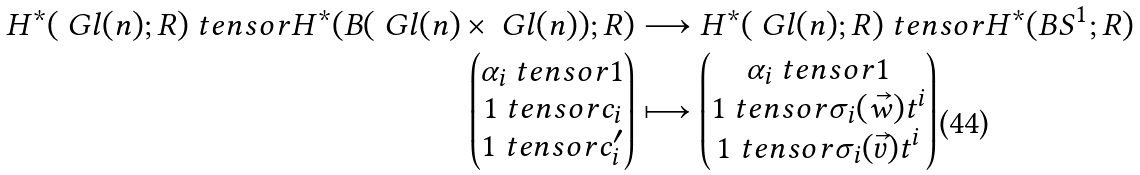Convert formula to latex. <formula><loc_0><loc_0><loc_500><loc_500>H ^ { * } ( \ G l ( n ) ; R ) \ t e n s o r H ^ { * } ( B ( \ G l ( n ) \times \ G l ( n ) ) ; R ) & \longrightarrow H ^ { * } ( \ G l ( n ) ; R ) \ t e n s o r H ^ { * } ( B S ^ { 1 } ; R ) \\ \begin{pmatrix} \alpha _ { i } \ t e n s o r 1 \\ 1 \ t e n s o r c _ { i } \\ 1 \ t e n s o r c _ { i } ^ { \prime } \end{pmatrix} & \longmapsto \begin{pmatrix} \alpha _ { i } \ t e n s o r 1 \\ 1 \ t e n s o r \sigma _ { i } ( \vec { w } ) t ^ { i } \\ 1 \ t e n s o r \sigma _ { i } ( \vec { v } ) t ^ { i } \end{pmatrix}</formula> 